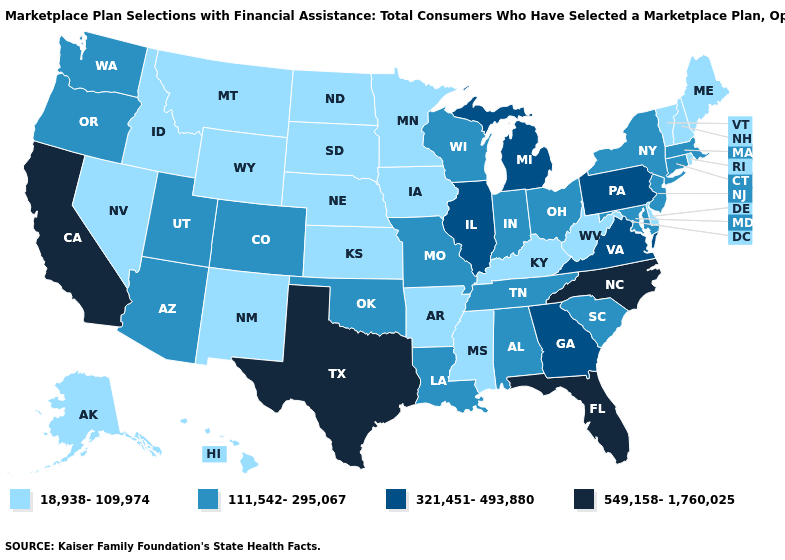Does New Jersey have the same value as Connecticut?
Give a very brief answer. Yes. Does South Carolina have the highest value in the USA?
Write a very short answer. No. Is the legend a continuous bar?
Give a very brief answer. No. Which states have the lowest value in the USA?
Quick response, please. Alaska, Arkansas, Delaware, Hawaii, Idaho, Iowa, Kansas, Kentucky, Maine, Minnesota, Mississippi, Montana, Nebraska, Nevada, New Hampshire, New Mexico, North Dakota, Rhode Island, South Dakota, Vermont, West Virginia, Wyoming. What is the lowest value in the MidWest?
Give a very brief answer. 18,938-109,974. What is the value of Massachusetts?
Keep it brief. 111,542-295,067. What is the value of Louisiana?
Keep it brief. 111,542-295,067. Among the states that border North Dakota , which have the lowest value?
Write a very short answer. Minnesota, Montana, South Dakota. What is the lowest value in the USA?
Keep it brief. 18,938-109,974. What is the value of Alabama?
Be succinct. 111,542-295,067. What is the value of Georgia?
Be succinct. 321,451-493,880. Does Illinois have the same value as Kentucky?
Answer briefly. No. Does Texas have the lowest value in the USA?
Answer briefly. No. What is the lowest value in states that border Kentucky?
Be succinct. 18,938-109,974. What is the value of North Carolina?
Keep it brief. 549,158-1,760,025. 